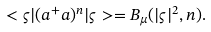<formula> <loc_0><loc_0><loc_500><loc_500>< \varsigma | ( a ^ { + } a ) ^ { n } | \varsigma > = B _ { \mu } ( | \varsigma | ^ { 2 } , n ) .</formula> 